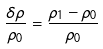<formula> <loc_0><loc_0><loc_500><loc_500>\frac { { \delta } { \rho } } { { \rho } _ { 0 } } = \frac { { \rho } _ { 1 } - { \rho } _ { 0 } } { { \rho } _ { 0 } }</formula> 